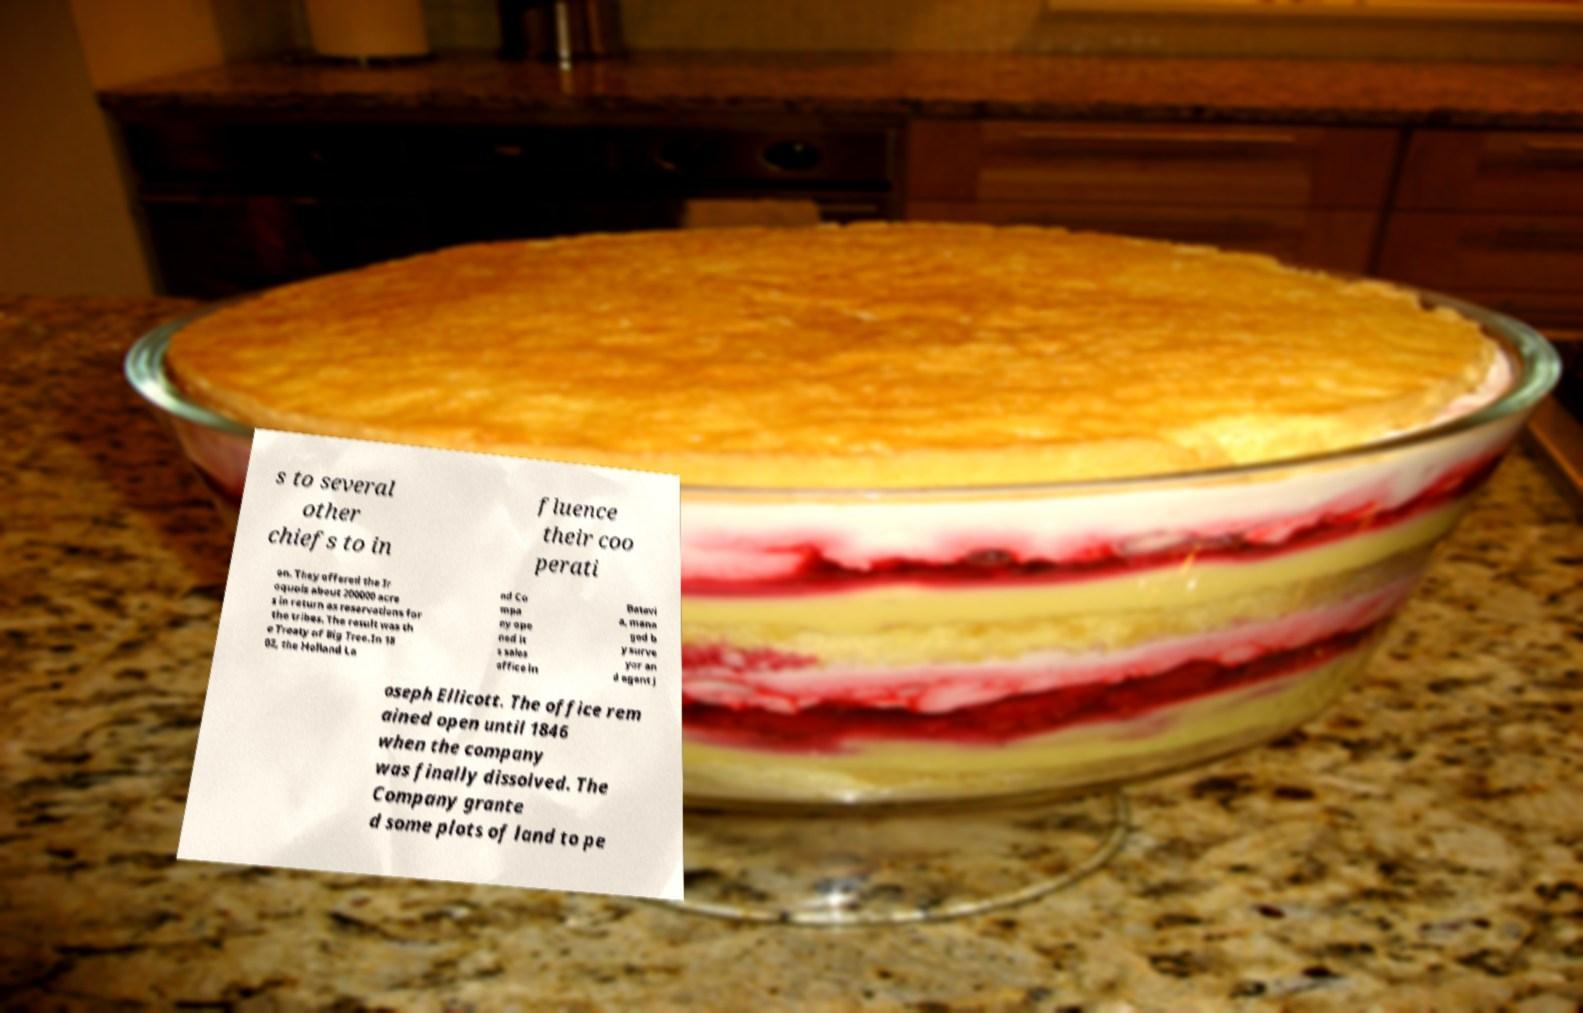Could you assist in decoding the text presented in this image and type it out clearly? s to several other chiefs to in fluence their coo perati on. They offered the Ir oquois about 200000 acre s in return as reservations for the tribes. The result was th e Treaty of Big Tree.In 18 02, the Holland La nd Co mpa ny ope ned it s sales office in Batavi a, mana ged b y surve yor an d agent J oseph Ellicott. The office rem ained open until 1846 when the company was finally dissolved. The Company grante d some plots of land to pe 